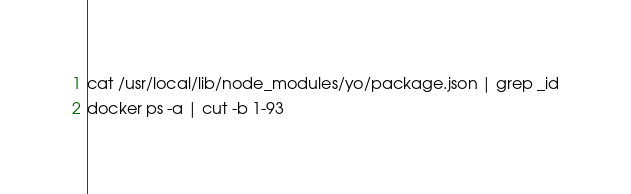Convert code to text. <code><loc_0><loc_0><loc_500><loc_500><_Bash_>cat /usr/local/lib/node_modules/yo/package.json | grep _id
docker ps -a | cut -b 1-93

</code> 